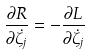<formula> <loc_0><loc_0><loc_500><loc_500>\frac { \partial R } { \partial \dot { \zeta } _ { j } } = - \frac { \partial L } { \partial \dot { \zeta } _ { j } }</formula> 